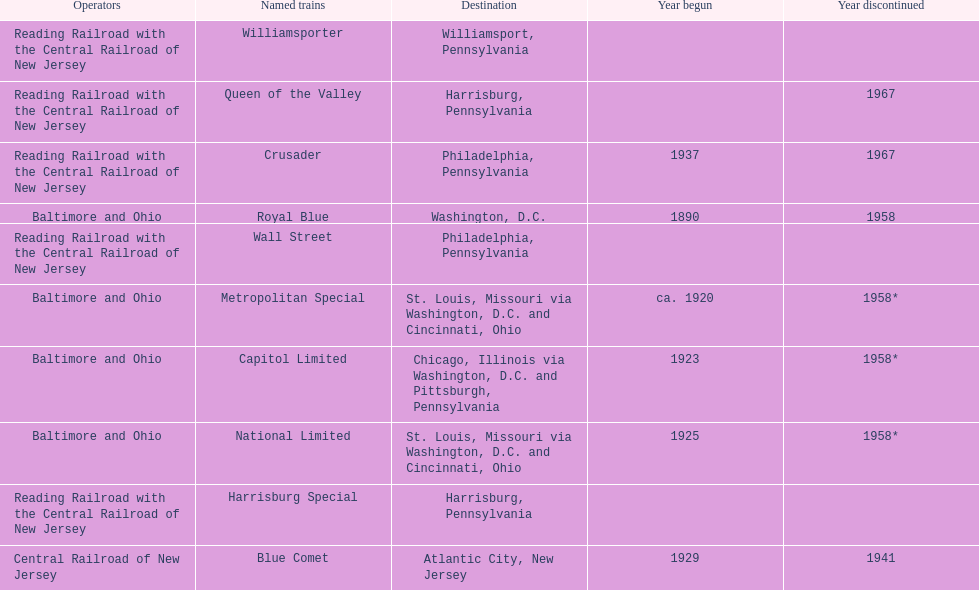Which train ran for the longest time? Royal Blue. 